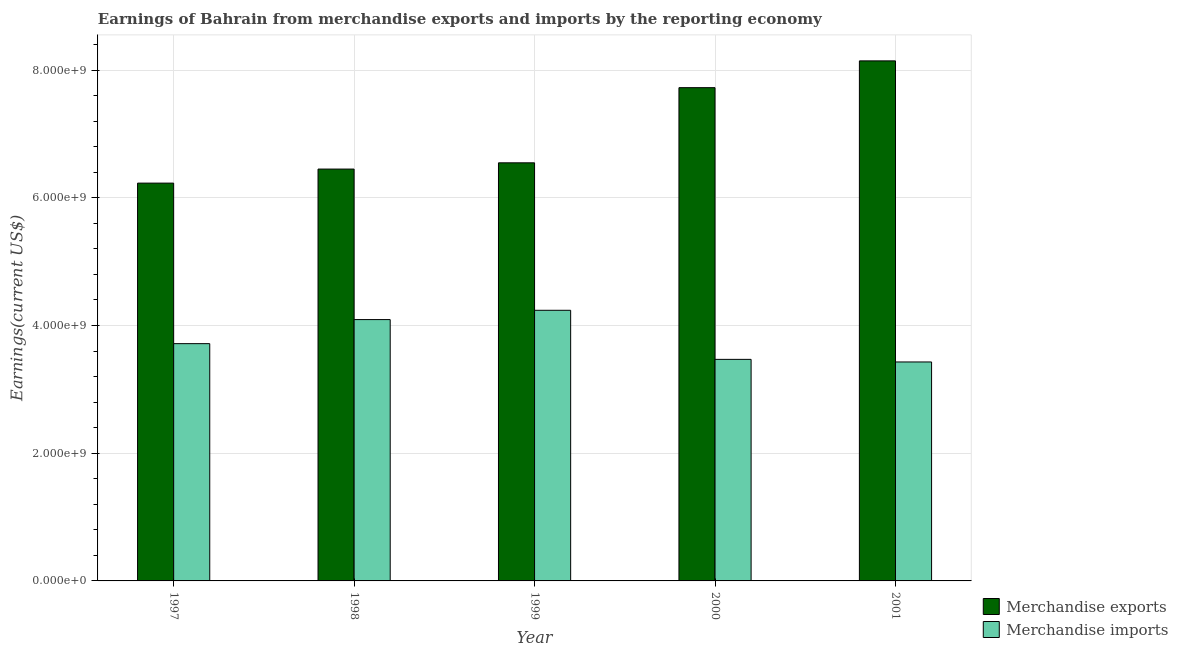Are the number of bars on each tick of the X-axis equal?
Your answer should be very brief. Yes. How many bars are there on the 5th tick from the left?
Keep it short and to the point. 2. How many bars are there on the 1st tick from the right?
Offer a very short reply. 2. What is the label of the 5th group of bars from the left?
Your answer should be very brief. 2001. In how many cases, is the number of bars for a given year not equal to the number of legend labels?
Your answer should be very brief. 0. What is the earnings from merchandise exports in 2000?
Give a very brief answer. 7.72e+09. Across all years, what is the maximum earnings from merchandise exports?
Give a very brief answer. 8.14e+09. Across all years, what is the minimum earnings from merchandise exports?
Offer a very short reply. 6.23e+09. In which year was the earnings from merchandise imports maximum?
Provide a short and direct response. 1999. What is the total earnings from merchandise exports in the graph?
Give a very brief answer. 3.51e+1. What is the difference between the earnings from merchandise exports in 1997 and that in 1998?
Provide a short and direct response. -2.20e+08. What is the difference between the earnings from merchandise exports in 2001 and the earnings from merchandise imports in 1998?
Provide a short and direct response. 1.69e+09. What is the average earnings from merchandise imports per year?
Your answer should be very brief. 3.79e+09. In the year 1997, what is the difference between the earnings from merchandise exports and earnings from merchandise imports?
Provide a short and direct response. 0. What is the ratio of the earnings from merchandise exports in 2000 to that in 2001?
Provide a succinct answer. 0.95. Is the difference between the earnings from merchandise exports in 1998 and 2001 greater than the difference between the earnings from merchandise imports in 1998 and 2001?
Offer a terse response. No. What is the difference between the highest and the second highest earnings from merchandise imports?
Provide a succinct answer. 1.46e+08. What is the difference between the highest and the lowest earnings from merchandise exports?
Offer a very short reply. 1.91e+09. In how many years, is the earnings from merchandise exports greater than the average earnings from merchandise exports taken over all years?
Keep it short and to the point. 2. What does the 2nd bar from the left in 2001 represents?
Offer a very short reply. Merchandise imports. What does the 1st bar from the right in 1999 represents?
Keep it short and to the point. Merchandise imports. What is the difference between two consecutive major ticks on the Y-axis?
Keep it short and to the point. 2.00e+09. Does the graph contain any zero values?
Your answer should be compact. No. Does the graph contain grids?
Keep it short and to the point. Yes. Where does the legend appear in the graph?
Your response must be concise. Bottom right. How many legend labels are there?
Provide a succinct answer. 2. How are the legend labels stacked?
Your answer should be compact. Vertical. What is the title of the graph?
Provide a short and direct response. Earnings of Bahrain from merchandise exports and imports by the reporting economy. Does "RDB nonconcessional" appear as one of the legend labels in the graph?
Provide a succinct answer. No. What is the label or title of the X-axis?
Your answer should be very brief. Year. What is the label or title of the Y-axis?
Keep it short and to the point. Earnings(current US$). What is the Earnings(current US$) of Merchandise exports in 1997?
Offer a very short reply. 6.23e+09. What is the Earnings(current US$) in Merchandise imports in 1997?
Offer a terse response. 3.72e+09. What is the Earnings(current US$) in Merchandise exports in 1998?
Provide a succinct answer. 6.45e+09. What is the Earnings(current US$) in Merchandise imports in 1998?
Keep it short and to the point. 4.09e+09. What is the Earnings(current US$) of Merchandise exports in 1999?
Give a very brief answer. 6.55e+09. What is the Earnings(current US$) in Merchandise imports in 1999?
Keep it short and to the point. 4.24e+09. What is the Earnings(current US$) of Merchandise exports in 2000?
Your response must be concise. 7.72e+09. What is the Earnings(current US$) of Merchandise imports in 2000?
Your response must be concise. 3.47e+09. What is the Earnings(current US$) of Merchandise exports in 2001?
Give a very brief answer. 8.14e+09. What is the Earnings(current US$) of Merchandise imports in 2001?
Offer a very short reply. 3.43e+09. Across all years, what is the maximum Earnings(current US$) of Merchandise exports?
Offer a terse response. 8.14e+09. Across all years, what is the maximum Earnings(current US$) of Merchandise imports?
Give a very brief answer. 4.24e+09. Across all years, what is the minimum Earnings(current US$) in Merchandise exports?
Your answer should be compact. 6.23e+09. Across all years, what is the minimum Earnings(current US$) of Merchandise imports?
Offer a terse response. 3.43e+09. What is the total Earnings(current US$) in Merchandise exports in the graph?
Offer a very short reply. 3.51e+1. What is the total Earnings(current US$) in Merchandise imports in the graph?
Give a very brief answer. 1.89e+1. What is the difference between the Earnings(current US$) in Merchandise exports in 1997 and that in 1998?
Ensure brevity in your answer.  -2.20e+08. What is the difference between the Earnings(current US$) in Merchandise imports in 1997 and that in 1998?
Make the answer very short. -3.77e+08. What is the difference between the Earnings(current US$) in Merchandise exports in 1997 and that in 1999?
Your answer should be very brief. -3.18e+08. What is the difference between the Earnings(current US$) of Merchandise imports in 1997 and that in 1999?
Provide a succinct answer. -5.22e+08. What is the difference between the Earnings(current US$) of Merchandise exports in 1997 and that in 2000?
Provide a short and direct response. -1.49e+09. What is the difference between the Earnings(current US$) of Merchandise imports in 1997 and that in 2000?
Your answer should be very brief. 2.46e+08. What is the difference between the Earnings(current US$) of Merchandise exports in 1997 and that in 2001?
Keep it short and to the point. -1.91e+09. What is the difference between the Earnings(current US$) of Merchandise imports in 1997 and that in 2001?
Your answer should be very brief. 2.87e+08. What is the difference between the Earnings(current US$) in Merchandise exports in 1998 and that in 1999?
Provide a succinct answer. -9.79e+07. What is the difference between the Earnings(current US$) of Merchandise imports in 1998 and that in 1999?
Provide a short and direct response. -1.46e+08. What is the difference between the Earnings(current US$) in Merchandise exports in 1998 and that in 2000?
Your response must be concise. -1.27e+09. What is the difference between the Earnings(current US$) in Merchandise imports in 1998 and that in 2000?
Keep it short and to the point. 6.23e+08. What is the difference between the Earnings(current US$) in Merchandise exports in 1998 and that in 2001?
Ensure brevity in your answer.  -1.69e+09. What is the difference between the Earnings(current US$) of Merchandise imports in 1998 and that in 2001?
Provide a succinct answer. 6.64e+08. What is the difference between the Earnings(current US$) in Merchandise exports in 1999 and that in 2000?
Ensure brevity in your answer.  -1.18e+09. What is the difference between the Earnings(current US$) of Merchandise imports in 1999 and that in 2000?
Offer a terse response. 7.68e+08. What is the difference between the Earnings(current US$) in Merchandise exports in 1999 and that in 2001?
Ensure brevity in your answer.  -1.60e+09. What is the difference between the Earnings(current US$) of Merchandise imports in 1999 and that in 2001?
Make the answer very short. 8.09e+08. What is the difference between the Earnings(current US$) in Merchandise exports in 2000 and that in 2001?
Your answer should be very brief. -4.19e+08. What is the difference between the Earnings(current US$) in Merchandise imports in 2000 and that in 2001?
Offer a very short reply. 4.07e+07. What is the difference between the Earnings(current US$) of Merchandise exports in 1997 and the Earnings(current US$) of Merchandise imports in 1998?
Make the answer very short. 2.14e+09. What is the difference between the Earnings(current US$) in Merchandise exports in 1997 and the Earnings(current US$) in Merchandise imports in 1999?
Offer a terse response. 1.99e+09. What is the difference between the Earnings(current US$) in Merchandise exports in 1997 and the Earnings(current US$) in Merchandise imports in 2000?
Give a very brief answer. 2.76e+09. What is the difference between the Earnings(current US$) of Merchandise exports in 1997 and the Earnings(current US$) of Merchandise imports in 2001?
Provide a short and direct response. 2.80e+09. What is the difference between the Earnings(current US$) in Merchandise exports in 1998 and the Earnings(current US$) in Merchandise imports in 1999?
Provide a succinct answer. 2.21e+09. What is the difference between the Earnings(current US$) in Merchandise exports in 1998 and the Earnings(current US$) in Merchandise imports in 2000?
Offer a very short reply. 2.98e+09. What is the difference between the Earnings(current US$) of Merchandise exports in 1998 and the Earnings(current US$) of Merchandise imports in 2001?
Your response must be concise. 3.02e+09. What is the difference between the Earnings(current US$) of Merchandise exports in 1999 and the Earnings(current US$) of Merchandise imports in 2000?
Your response must be concise. 3.08e+09. What is the difference between the Earnings(current US$) of Merchandise exports in 1999 and the Earnings(current US$) of Merchandise imports in 2001?
Your response must be concise. 3.12e+09. What is the difference between the Earnings(current US$) in Merchandise exports in 2000 and the Earnings(current US$) in Merchandise imports in 2001?
Provide a succinct answer. 4.30e+09. What is the average Earnings(current US$) of Merchandise exports per year?
Provide a short and direct response. 7.02e+09. What is the average Earnings(current US$) of Merchandise imports per year?
Provide a short and direct response. 3.79e+09. In the year 1997, what is the difference between the Earnings(current US$) of Merchandise exports and Earnings(current US$) of Merchandise imports?
Keep it short and to the point. 2.51e+09. In the year 1998, what is the difference between the Earnings(current US$) of Merchandise exports and Earnings(current US$) of Merchandise imports?
Provide a succinct answer. 2.36e+09. In the year 1999, what is the difference between the Earnings(current US$) of Merchandise exports and Earnings(current US$) of Merchandise imports?
Your answer should be compact. 2.31e+09. In the year 2000, what is the difference between the Earnings(current US$) of Merchandise exports and Earnings(current US$) of Merchandise imports?
Ensure brevity in your answer.  4.25e+09. In the year 2001, what is the difference between the Earnings(current US$) in Merchandise exports and Earnings(current US$) in Merchandise imports?
Offer a terse response. 4.72e+09. What is the ratio of the Earnings(current US$) in Merchandise exports in 1997 to that in 1998?
Your answer should be compact. 0.97. What is the ratio of the Earnings(current US$) in Merchandise imports in 1997 to that in 1998?
Provide a succinct answer. 0.91. What is the ratio of the Earnings(current US$) of Merchandise exports in 1997 to that in 1999?
Your response must be concise. 0.95. What is the ratio of the Earnings(current US$) in Merchandise imports in 1997 to that in 1999?
Provide a succinct answer. 0.88. What is the ratio of the Earnings(current US$) in Merchandise exports in 1997 to that in 2000?
Keep it short and to the point. 0.81. What is the ratio of the Earnings(current US$) in Merchandise imports in 1997 to that in 2000?
Your answer should be compact. 1.07. What is the ratio of the Earnings(current US$) in Merchandise exports in 1997 to that in 2001?
Offer a very short reply. 0.77. What is the ratio of the Earnings(current US$) of Merchandise imports in 1997 to that in 2001?
Provide a short and direct response. 1.08. What is the ratio of the Earnings(current US$) in Merchandise exports in 1998 to that in 1999?
Provide a short and direct response. 0.99. What is the ratio of the Earnings(current US$) in Merchandise imports in 1998 to that in 1999?
Your answer should be compact. 0.97. What is the ratio of the Earnings(current US$) in Merchandise exports in 1998 to that in 2000?
Your answer should be very brief. 0.83. What is the ratio of the Earnings(current US$) of Merchandise imports in 1998 to that in 2000?
Provide a succinct answer. 1.18. What is the ratio of the Earnings(current US$) in Merchandise exports in 1998 to that in 2001?
Make the answer very short. 0.79. What is the ratio of the Earnings(current US$) of Merchandise imports in 1998 to that in 2001?
Give a very brief answer. 1.19. What is the ratio of the Earnings(current US$) of Merchandise exports in 1999 to that in 2000?
Make the answer very short. 0.85. What is the ratio of the Earnings(current US$) in Merchandise imports in 1999 to that in 2000?
Provide a short and direct response. 1.22. What is the ratio of the Earnings(current US$) of Merchandise exports in 1999 to that in 2001?
Offer a very short reply. 0.8. What is the ratio of the Earnings(current US$) in Merchandise imports in 1999 to that in 2001?
Offer a terse response. 1.24. What is the ratio of the Earnings(current US$) of Merchandise exports in 2000 to that in 2001?
Your answer should be compact. 0.95. What is the ratio of the Earnings(current US$) in Merchandise imports in 2000 to that in 2001?
Your answer should be very brief. 1.01. What is the difference between the highest and the second highest Earnings(current US$) in Merchandise exports?
Give a very brief answer. 4.19e+08. What is the difference between the highest and the second highest Earnings(current US$) in Merchandise imports?
Make the answer very short. 1.46e+08. What is the difference between the highest and the lowest Earnings(current US$) of Merchandise exports?
Your answer should be very brief. 1.91e+09. What is the difference between the highest and the lowest Earnings(current US$) of Merchandise imports?
Your answer should be very brief. 8.09e+08. 